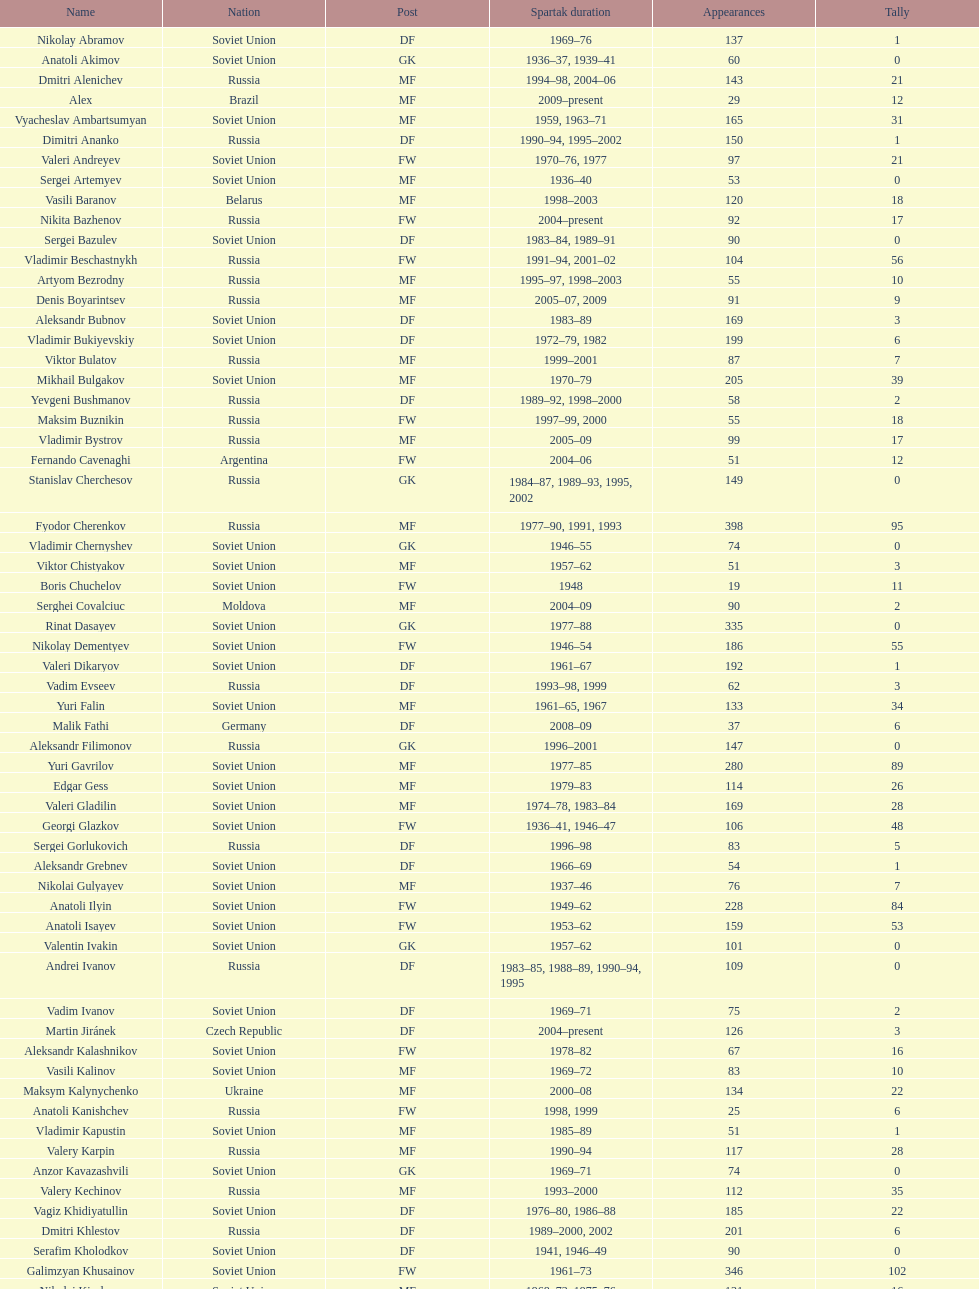Who had the highest number of appearances? Fyodor Cherenkov. 